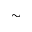<formula> <loc_0><loc_0><loc_500><loc_500>\sim</formula> 